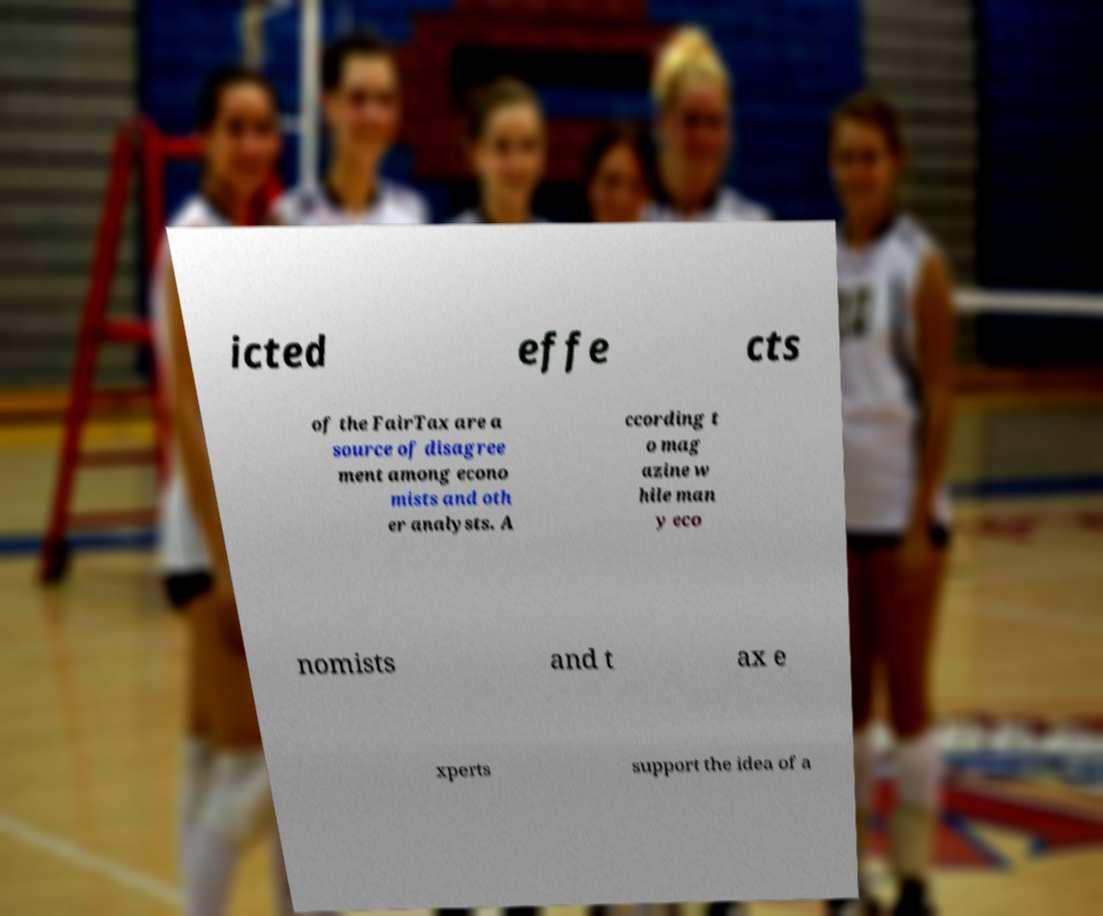Could you assist in decoding the text presented in this image and type it out clearly? icted effe cts of the FairTax are a source of disagree ment among econo mists and oth er analysts. A ccording t o mag azine w hile man y eco nomists and t ax e xperts support the idea of a 